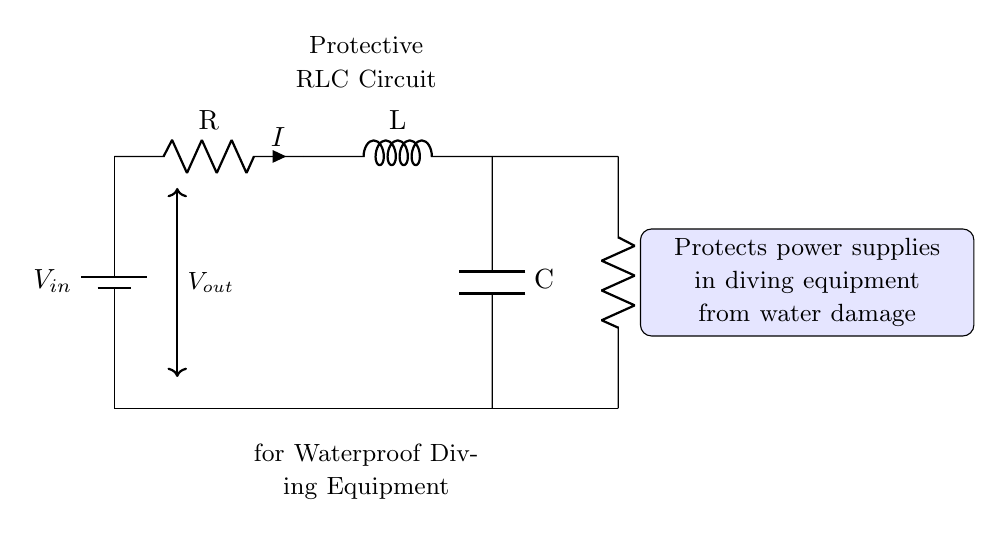What is the input voltage of the circuit? The input voltage, represented as \( V_{in} \), is the voltage supplied to the circuit by the battery. It's typically the power source for the system.
Answer: V in What components are present in the circuit? The circuit contains a battery, a resistor, an inductor, and a capacitor, as well as a load resistor. These components are fundamental to the functioning of an RLC circuit.
Answer: battery, resistor, inductor, capacitor What type of circuit is this? This is a protective RLC circuit, specifically designed to manage and filter electrical signals while preventing water damage to diving equipment power supplies.
Answer: RLC circuit How many resistors are present in the circuit? There are two resistors in this circuit: one is part of the RLC structure and the other is the load resistor connected downstream.
Answer: 2 What does the load resistor do in this circuit? The load resistor, labeled as \( R_{load} \), helps to ensure that the output voltage \( V_{out} \) is delivered effectively to the diving equipment while providing a load for the circuit.
Answer: Deliver voltage How does this circuit protect against water damage? The RLC configuration stabilizes the voltage and current, preventing sudden spikes that could result from water exposure, thus protecting the sensitive internal components of the power supply.
Answer: Stabilizes voltage What is the current flowing through the resistor? The current flowing through the resistor is denoted as \( I \), which is determined by the input voltage and the resistances present in the circuit according to Ohm's law.
Answer: I 